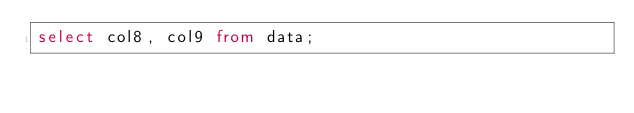<code> <loc_0><loc_0><loc_500><loc_500><_SQL_>select col8, col9 from data;</code> 